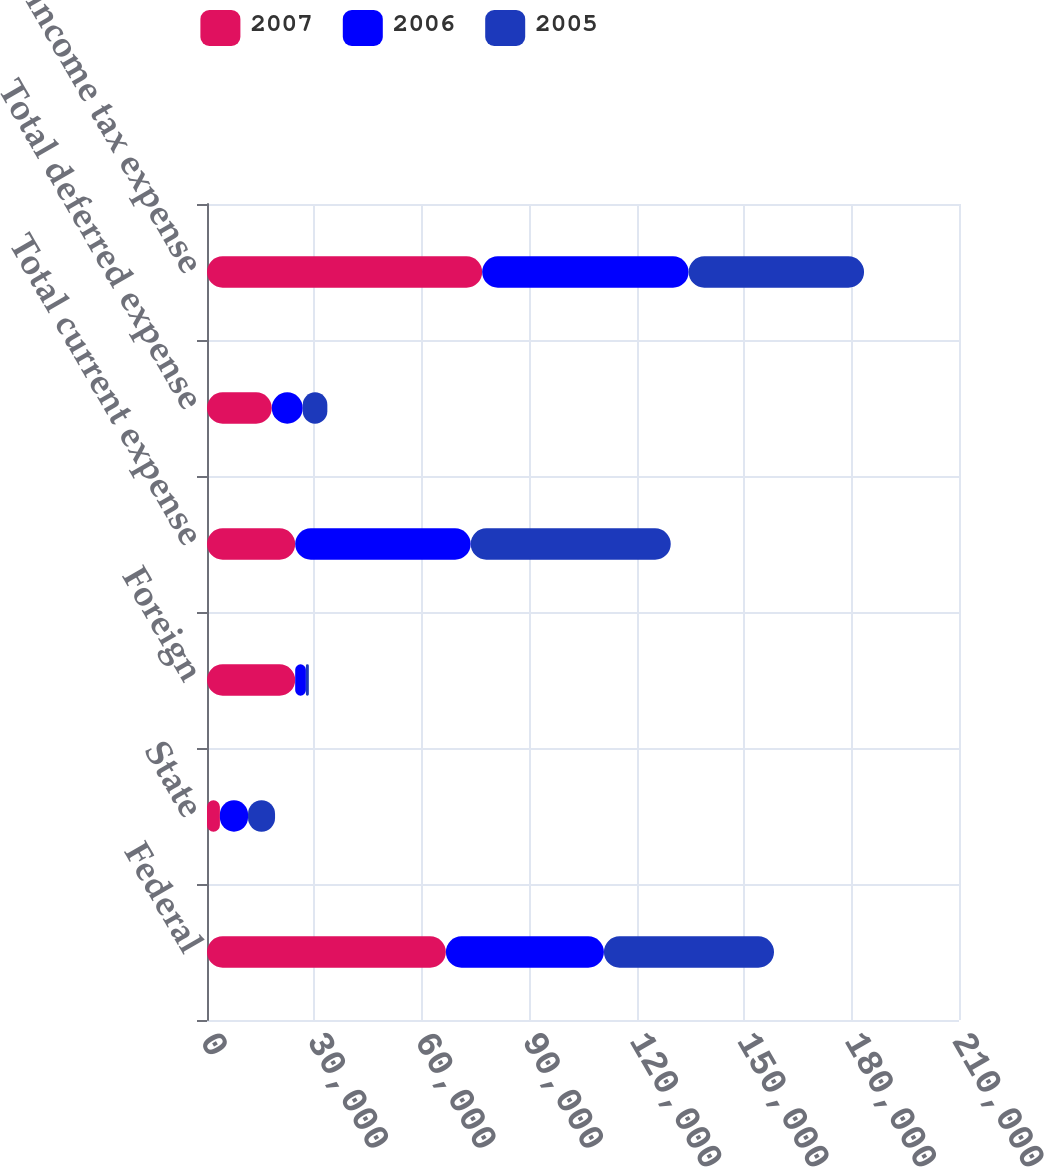Convert chart. <chart><loc_0><loc_0><loc_500><loc_500><stacked_bar_chart><ecel><fcel>Federal<fcel>State<fcel>Foreign<fcel>Total current expense<fcel>Total deferred expense<fcel>Total income tax expense<nl><fcel>2007<fcel>66701<fcel>3600<fcel>24629<fcel>24629<fcel>18088<fcel>76842<nl><fcel>2006<fcel>44139<fcel>7855<fcel>2987<fcel>49007<fcel>8646<fcel>57653<nl><fcel>2005<fcel>47499<fcel>7549<fcel>819<fcel>55867<fcel>6874<fcel>48993<nl></chart> 